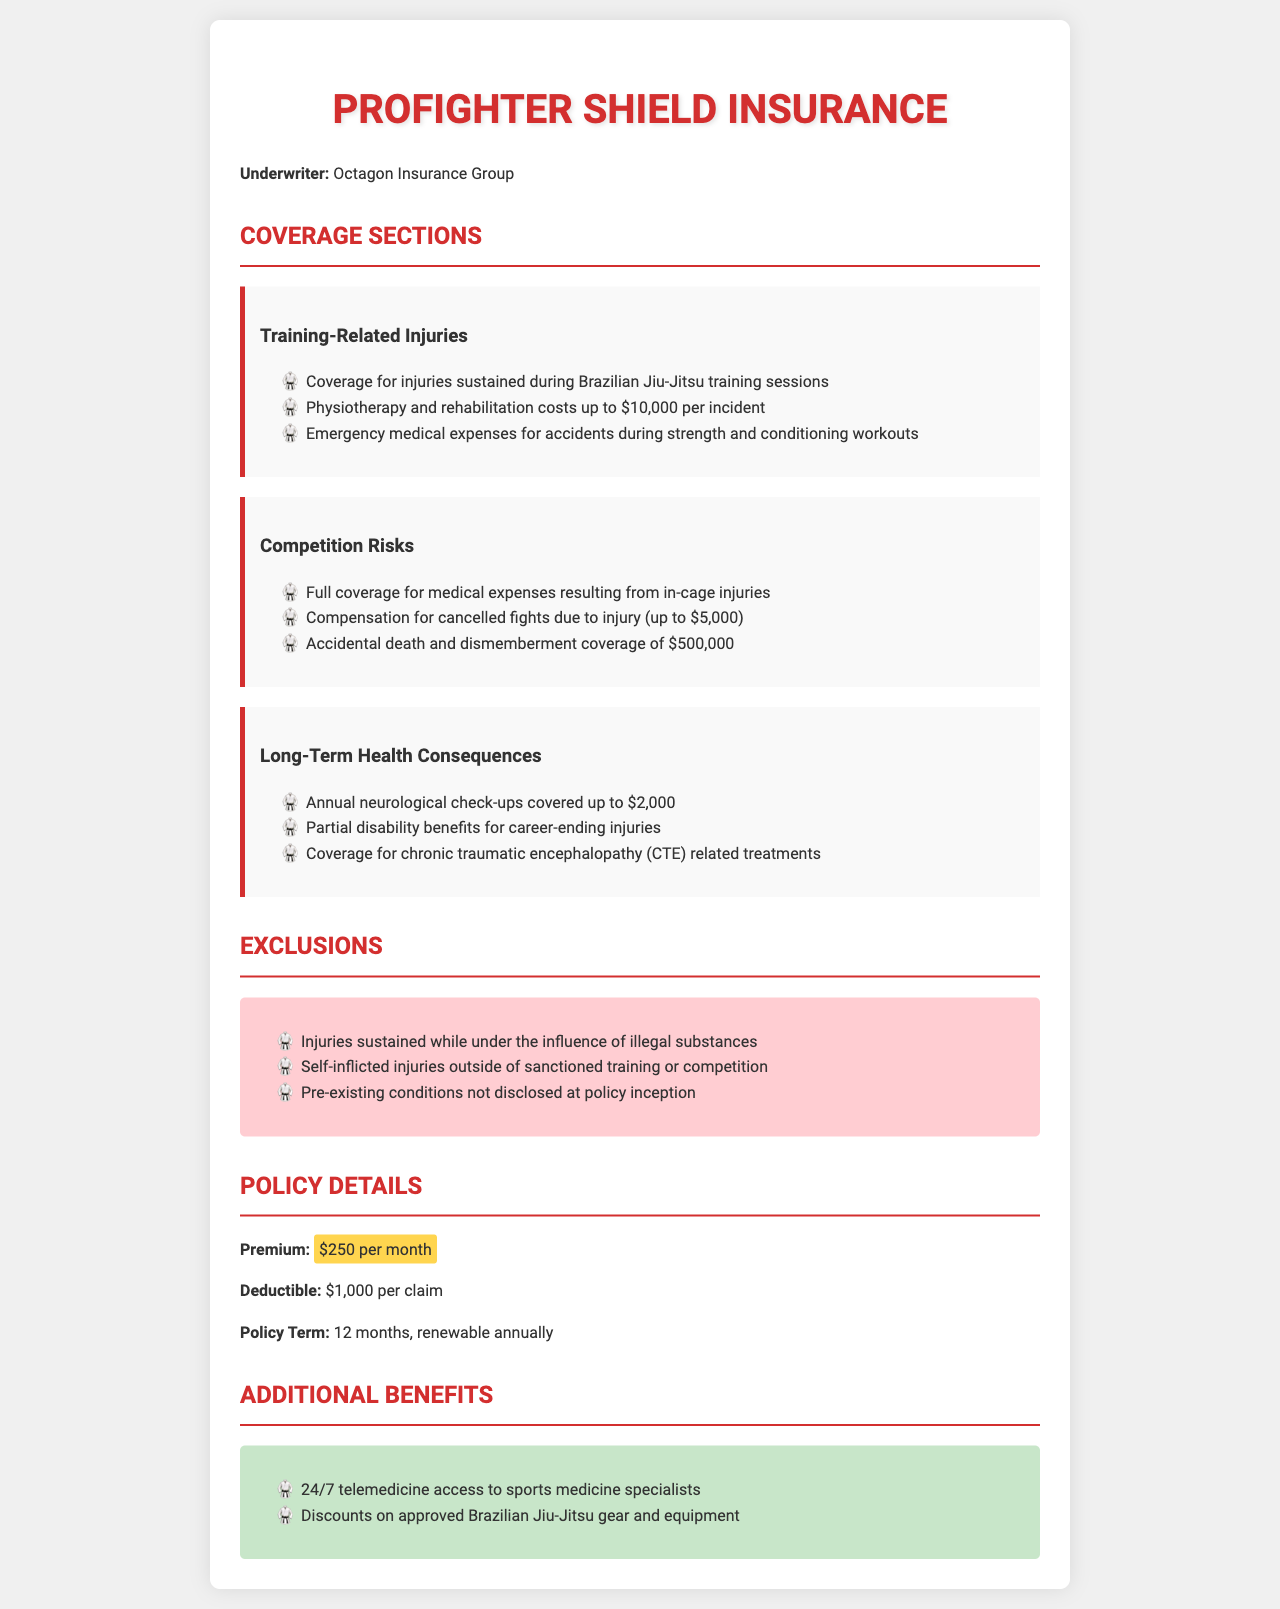what is the premium amount? The premium is specified in the document as $250 per month.
Answer: $250 per month what type of injuries are covered during training? The document indicates coverage for injuries sustained during Brazilian Jiu-Jitsu training sessions.
Answer: Brazilian Jiu-Jitsu training injuries what is the coverage limit for physiotherapy? Coverage for physiotherapy and rehabilitation costs is up to $10,000 per incident.
Answer: $10,000 what is the accidental death and dismemberment coverage? The policy provides accidental death and dismemberment coverage of $500,000.
Answer: $500,000 what exclusions are mentioned in the policy? The exclusions include injuries while under the influence of illegal substances.
Answer: Injuries while under influence what is the deductible amount for claims? The deductible for claims is stated as $1,000 per claim.
Answer: $1,000 how much is covered for neurological check-ups? Annual neurological check-ups are covered up to $2,000.
Answer: $2,000 what benefit is provided for cancelled fights? Compensation for cancelled fights due to injury is up to $5,000.
Answer: $5,000 what are the additional benefits mentioned in the policy? Additional benefits include 24/7 telemedicine access to sports medicine specialists.
Answer: 24/7 telemedicine access 